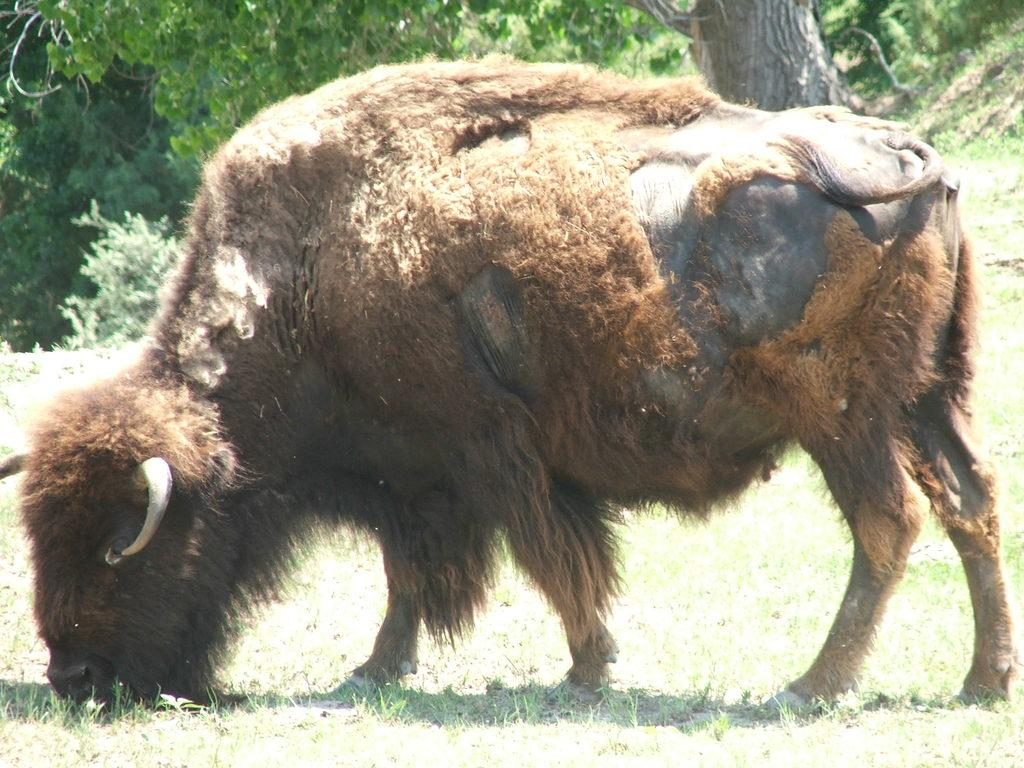What type of animal is in the image? The type of animal cannot be determined from the provided facts. Where is the animal located in the image? The animal is on the grass in the image. What can be seen in the background of the image? There is a tree trunk and plants in the background of the image. What brand of boot is being advertised in the image? There is no advertisement or boot present in the image. 